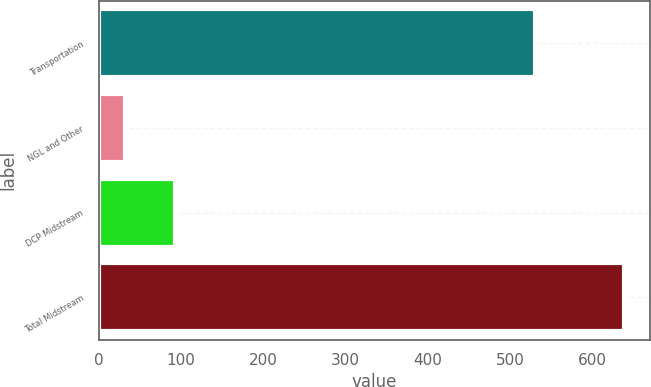Convert chart to OTSL. <chart><loc_0><loc_0><loc_500><loc_500><bar_chart><fcel>Transportation<fcel>NGL and Other<fcel>DCP Midstream<fcel>Total Midstream<nl><fcel>530<fcel>32<fcel>92.6<fcel>638<nl></chart> 